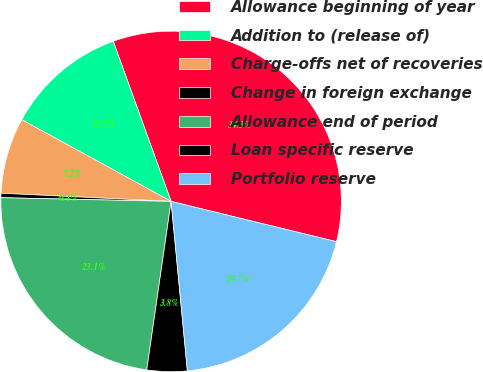Convert chart. <chart><loc_0><loc_0><loc_500><loc_500><pie_chart><fcel>Allowance beginning of year<fcel>Addition to (release of)<fcel>Charge-offs net of recoveries<fcel>Change in foreign exchange<fcel>Allowance end of period<fcel>Loan specific reserve<fcel>Portfolio reserve<nl><fcel>34.32%<fcel>11.51%<fcel>7.2%<fcel>0.42%<fcel>23.06%<fcel>3.81%<fcel>19.67%<nl></chart> 